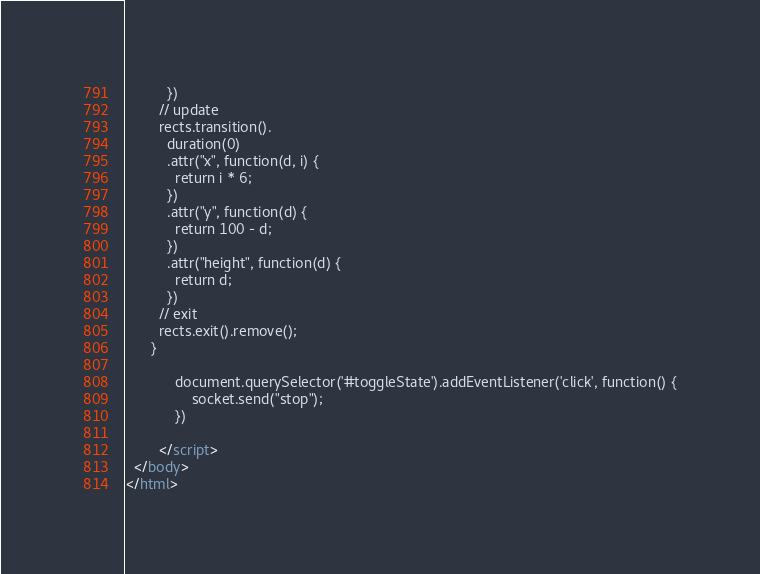Convert code to text. <code><loc_0><loc_0><loc_500><loc_500><_HTML_>          })
        // update
        rects.transition().
          duration(0)
          .attr("x", function(d, i) {
            return i * 6;
          })
          .attr("y", function(d) {
            return 100 - d;
          })
          .attr("height", function(d) {
            return d;
          })
        // exit
        rects.exit().remove();
      }

			document.querySelector('#toggleState').addEventListener('click', function() {
				socket.send("stop");
			})

		</script>
  </body>
</html>
</code> 